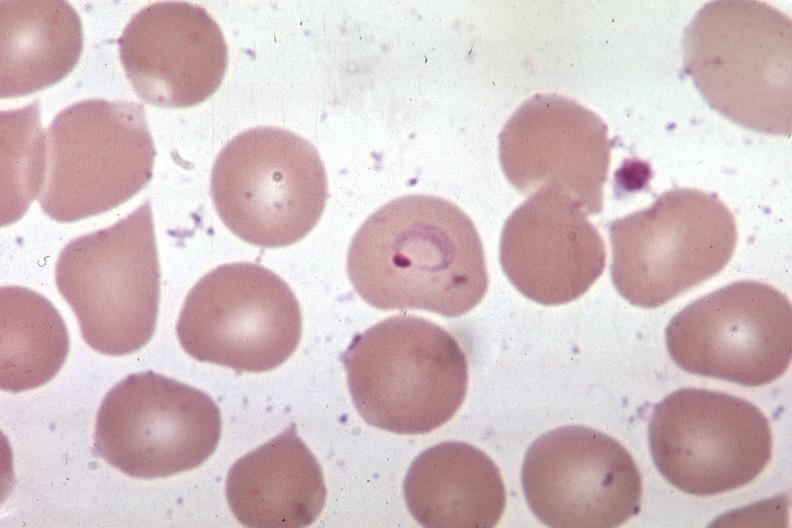s this great toe present?
Answer the question using a single word or phrase. No 